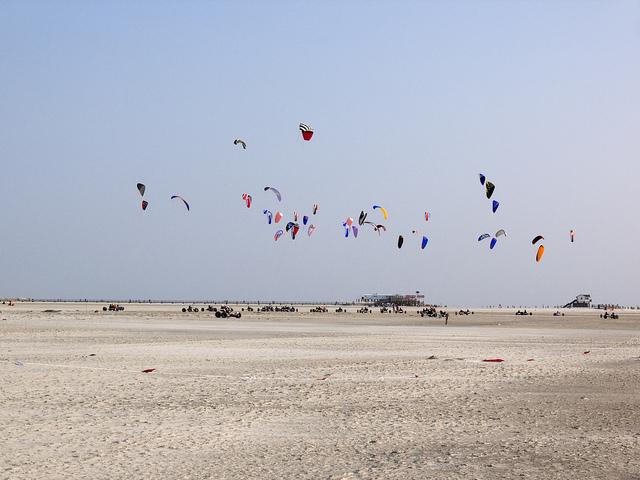Are there many kites in the sky?
Short answer required. Yes. Is this a desert location?
Give a very brief answer. Yes. What activity is happening on the beach?
Write a very short answer. Kite flying. How many kites are there?
Keep it brief. 20. What can fly in the picture?
Quick response, please. Kites. Can you see sand?
Give a very brief answer. Yes. 